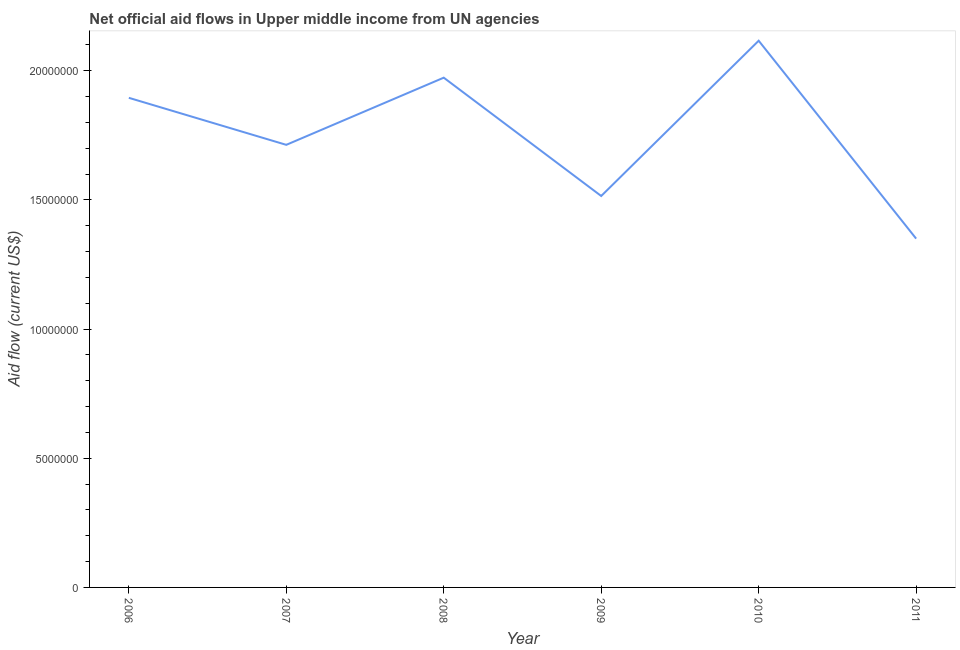What is the net official flows from un agencies in 2011?
Offer a terse response. 1.35e+07. Across all years, what is the maximum net official flows from un agencies?
Give a very brief answer. 2.12e+07. Across all years, what is the minimum net official flows from un agencies?
Make the answer very short. 1.35e+07. In which year was the net official flows from un agencies minimum?
Your answer should be compact. 2011. What is the sum of the net official flows from un agencies?
Your response must be concise. 1.06e+08. What is the difference between the net official flows from un agencies in 2007 and 2011?
Offer a very short reply. 3.63e+06. What is the average net official flows from un agencies per year?
Ensure brevity in your answer.  1.76e+07. What is the median net official flows from un agencies?
Ensure brevity in your answer.  1.80e+07. What is the ratio of the net official flows from un agencies in 2007 to that in 2011?
Make the answer very short. 1.27. Is the net official flows from un agencies in 2006 less than that in 2010?
Keep it short and to the point. Yes. What is the difference between the highest and the second highest net official flows from un agencies?
Your answer should be very brief. 1.43e+06. Is the sum of the net official flows from un agencies in 2010 and 2011 greater than the maximum net official flows from un agencies across all years?
Keep it short and to the point. Yes. What is the difference between the highest and the lowest net official flows from un agencies?
Give a very brief answer. 7.66e+06. In how many years, is the net official flows from un agencies greater than the average net official flows from un agencies taken over all years?
Make the answer very short. 3. How many lines are there?
Make the answer very short. 1. Are the values on the major ticks of Y-axis written in scientific E-notation?
Your answer should be compact. No. Does the graph contain grids?
Keep it short and to the point. No. What is the title of the graph?
Give a very brief answer. Net official aid flows in Upper middle income from UN agencies. What is the label or title of the Y-axis?
Keep it short and to the point. Aid flow (current US$). What is the Aid flow (current US$) in 2006?
Your answer should be compact. 1.90e+07. What is the Aid flow (current US$) of 2007?
Offer a terse response. 1.71e+07. What is the Aid flow (current US$) in 2008?
Ensure brevity in your answer.  1.97e+07. What is the Aid flow (current US$) of 2009?
Keep it short and to the point. 1.52e+07. What is the Aid flow (current US$) in 2010?
Give a very brief answer. 2.12e+07. What is the Aid flow (current US$) of 2011?
Keep it short and to the point. 1.35e+07. What is the difference between the Aid flow (current US$) in 2006 and 2007?
Keep it short and to the point. 1.82e+06. What is the difference between the Aid flow (current US$) in 2006 and 2008?
Your answer should be very brief. -7.80e+05. What is the difference between the Aid flow (current US$) in 2006 and 2009?
Your response must be concise. 3.80e+06. What is the difference between the Aid flow (current US$) in 2006 and 2010?
Your response must be concise. -2.21e+06. What is the difference between the Aid flow (current US$) in 2006 and 2011?
Ensure brevity in your answer.  5.45e+06. What is the difference between the Aid flow (current US$) in 2007 and 2008?
Provide a succinct answer. -2.60e+06. What is the difference between the Aid flow (current US$) in 2007 and 2009?
Provide a short and direct response. 1.98e+06. What is the difference between the Aid flow (current US$) in 2007 and 2010?
Offer a terse response. -4.03e+06. What is the difference between the Aid flow (current US$) in 2007 and 2011?
Your answer should be compact. 3.63e+06. What is the difference between the Aid flow (current US$) in 2008 and 2009?
Offer a terse response. 4.58e+06. What is the difference between the Aid flow (current US$) in 2008 and 2010?
Ensure brevity in your answer.  -1.43e+06. What is the difference between the Aid flow (current US$) in 2008 and 2011?
Offer a terse response. 6.23e+06. What is the difference between the Aid flow (current US$) in 2009 and 2010?
Your answer should be very brief. -6.01e+06. What is the difference between the Aid flow (current US$) in 2009 and 2011?
Your response must be concise. 1.65e+06. What is the difference between the Aid flow (current US$) in 2010 and 2011?
Give a very brief answer. 7.66e+06. What is the ratio of the Aid flow (current US$) in 2006 to that in 2007?
Provide a short and direct response. 1.11. What is the ratio of the Aid flow (current US$) in 2006 to that in 2008?
Provide a short and direct response. 0.96. What is the ratio of the Aid flow (current US$) in 2006 to that in 2009?
Offer a terse response. 1.25. What is the ratio of the Aid flow (current US$) in 2006 to that in 2010?
Your answer should be very brief. 0.9. What is the ratio of the Aid flow (current US$) in 2006 to that in 2011?
Your response must be concise. 1.4. What is the ratio of the Aid flow (current US$) in 2007 to that in 2008?
Provide a succinct answer. 0.87. What is the ratio of the Aid flow (current US$) in 2007 to that in 2009?
Your answer should be very brief. 1.13. What is the ratio of the Aid flow (current US$) in 2007 to that in 2010?
Ensure brevity in your answer.  0.81. What is the ratio of the Aid flow (current US$) in 2007 to that in 2011?
Your response must be concise. 1.27. What is the ratio of the Aid flow (current US$) in 2008 to that in 2009?
Offer a very short reply. 1.3. What is the ratio of the Aid flow (current US$) in 2008 to that in 2010?
Keep it short and to the point. 0.93. What is the ratio of the Aid flow (current US$) in 2008 to that in 2011?
Ensure brevity in your answer.  1.46. What is the ratio of the Aid flow (current US$) in 2009 to that in 2010?
Give a very brief answer. 0.72. What is the ratio of the Aid flow (current US$) in 2009 to that in 2011?
Your answer should be very brief. 1.12. What is the ratio of the Aid flow (current US$) in 2010 to that in 2011?
Your answer should be compact. 1.57. 